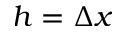Convert formula to latex. <formula><loc_0><loc_0><loc_500><loc_500>h = \Delta x</formula> 